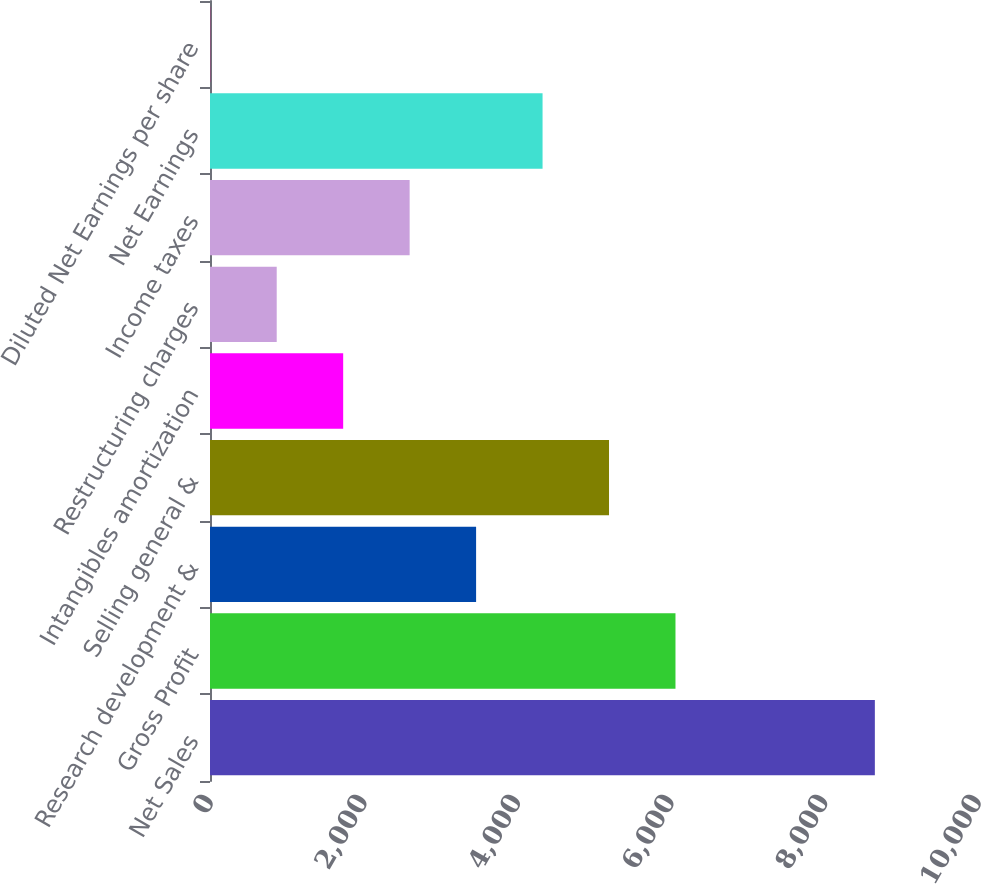<chart> <loc_0><loc_0><loc_500><loc_500><bar_chart><fcel>Net Sales<fcel>Gross Profit<fcel>Research development &<fcel>Selling general &<fcel>Intangibles amortization<fcel>Restructuring charges<fcel>Income taxes<fcel>Net Earnings<fcel>Diluted Net Earnings per share<nl><fcel>8657<fcel>6060.91<fcel>3464.83<fcel>5195.55<fcel>1734.11<fcel>868.75<fcel>2599.47<fcel>4330.19<fcel>3.39<nl></chart> 